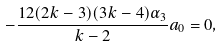<formula> <loc_0><loc_0><loc_500><loc_500>- \frac { 1 2 ( 2 k - 3 ) ( 3 k - 4 ) \alpha _ { 3 } } { k - 2 } a _ { 0 } = 0 ,</formula> 